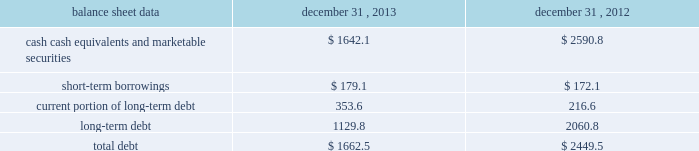Management 2019s discussion and analysis of financial condition and results of operations 2013 ( continued ) ( amounts in millions , except per share amounts ) net cash used in investing activities during 2012 primarily related to payments for capital expenditures and acquisitions , partially offset by the net proceeds of $ 94.8 received from the sale of our remaining holdings in facebook .
Capital expenditures of $ 169.2 primarily related to computer hardware and software , and leasehold improvements .
Capital expenditures increased in 2012 compared to the prior year , primarily due to an increase in leasehold improvements made during the year .
Payments for acquisitions of $ 145.5 primarily related to payments for new acquisitions .
Financing activities net cash used in financing activities during 2013 primarily related to the purchase of long-term debt , the repurchase of our common stock , and payment of dividends .
We redeemed all $ 600.0 in aggregate principal amount of our 10.00% ( 10.00 % ) notes .
In addition , we repurchased 31.8 shares of our common stock for an aggregate cost of $ 481.8 , including fees , and made dividend payments of $ 126.0 on our common stock .
Net cash provided by financing activities during 2012 primarily reflected net proceeds from our debt transactions .
We issued $ 300.0 in aggregate principal amount of 2.25% ( 2.25 % ) senior notes due 2017 ( the 201c2.25% ( 201c2.25 % ) notes 201d ) , $ 500.0 in aggregate principal amount of 3.75% ( 3.75 % ) senior notes due 2023 ( the 201c3.75% ( 201c3.75 % ) notes 201d ) and $ 250.0 in aggregate principal amount of 4.00% ( 4.00 % ) senior notes due 2022 ( the 201c4.00% ( 201c4.00 % ) notes 201d ) .
The proceeds from the issuance of the 4.00% ( 4.00 % ) notes were applied towards the repurchase and redemption of $ 399.6 in aggregate principal amount of our 4.25% ( 4.25 % ) notes .
Offsetting the net proceeds from our debt transactions was the repurchase of 32.7 shares of our common stock for an aggregate cost of $ 350.5 , including fees , and dividend payments of $ 103.4 on our common stock .
Foreign exchange rate changes the effect of foreign exchange rate changes on cash and cash equivalents included in the consolidated statements of cash flows resulted in a decrease of $ 94.1 in 2013 .
The decrease was primarily a result of the u.s .
Dollar being stronger than several foreign currencies , including the australian dollar , brazilian real , japanese yen , canadian dollar and south african rand as of december 31 , 2013 compared to december 31 , 2012 .
The effect of foreign exchange rate changes on cash and cash equivalents included in the consolidated statements of cash flows resulted in a decrease of $ 6.2 in 2012 .
The decrease was a result of the u.s .
Dollar being stronger than several foreign currencies , including the brazilian real and south african rand , offset by the u.s .
Dollar being weaker than other foreign currencies , including the australian dollar , british pound and the euro , as of as of december 31 , 2012 compared to december 31 , 2011. .
Liquidity outlook we expect our cash flow from operations , cash and cash equivalents to be sufficient to meet our anticipated operating requirements at a minimum for the next twelve months .
We also have a committed corporate credit facility as well as uncommitted facilities available to support our operating needs .
We continue to maintain a disciplined approach to managing liquidity , with flexibility over significant uses of cash , including our capital expenditures , cash used for new acquisitions , our common stock repurchase program and our common stock dividends. .
What are the total current liabilities for 2013? 
Computations: ((1662.5 - 1129.8) / 1129.8)
Answer: 0.4715. 